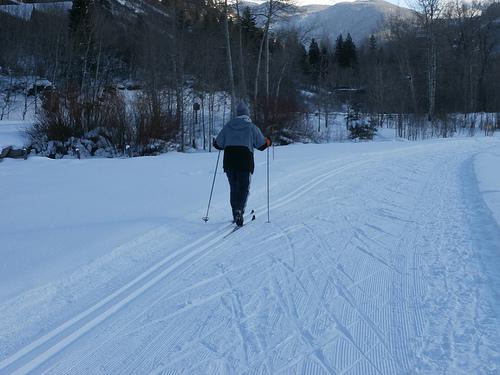Question: what is in the distance?
Choices:
A. Snow.
B. A mountain.
C. Trees.
D. People.
Answer with the letter. Answer: B Question: what is the person doing?
Choices:
A. Falling.
B. Ski lift.
C. Skiing.
D. Snowboarding.
Answer with the letter. Answer: C Question: what is the person holding?
Choices:
A. Cell phone.
B. Ski poles.
C. Goggles.
D. Gloves.
Answer with the letter. Answer: B Question: what is on the ground?
Choices:
A. Bad skiers.
B. Snow.
C. Kids playing.
D. Dogs.
Answer with the letter. Answer: B Question: where is the person?
Choices:
A. On a slope.
B. In the lodge.
C. The infirmary.
D. Snowboarding.
Answer with the letter. Answer: A 